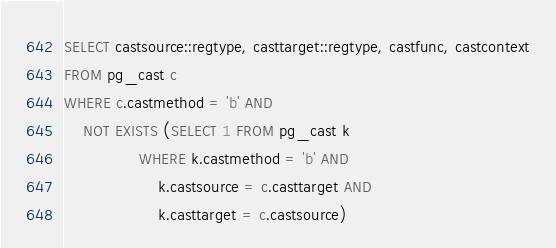<code> <loc_0><loc_0><loc_500><loc_500><_SQL_>SELECT castsource::regtype, casttarget::regtype, castfunc, castcontext
FROM pg_cast c
WHERE c.castmethod = 'b' AND
    NOT EXISTS (SELECT 1 FROM pg_cast k
                WHERE k.castmethod = 'b' AND
                    k.castsource = c.casttarget AND
                    k.casttarget = c.castsource)
</code> 